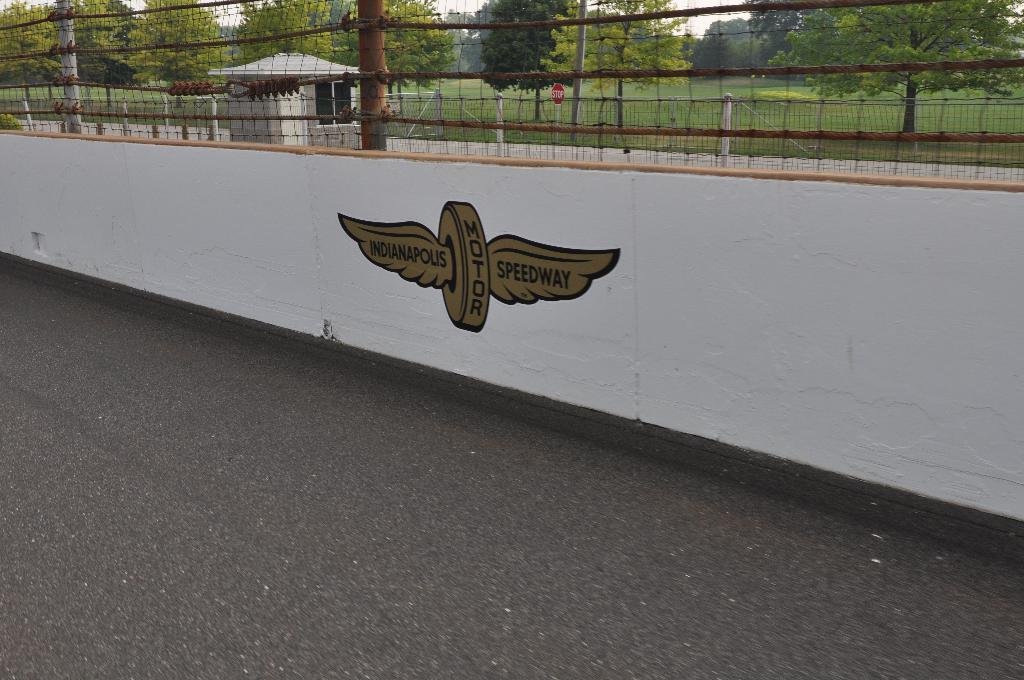Describe this image in one or two sentences. At the bottom of the picture, we see the road. Beside that, we see a white wall. Behind that, we see the fence. Behind that, we see a nut which looks like a gazebo. There are trees in the background. We even see a board in red color with "STOP" written on it. 